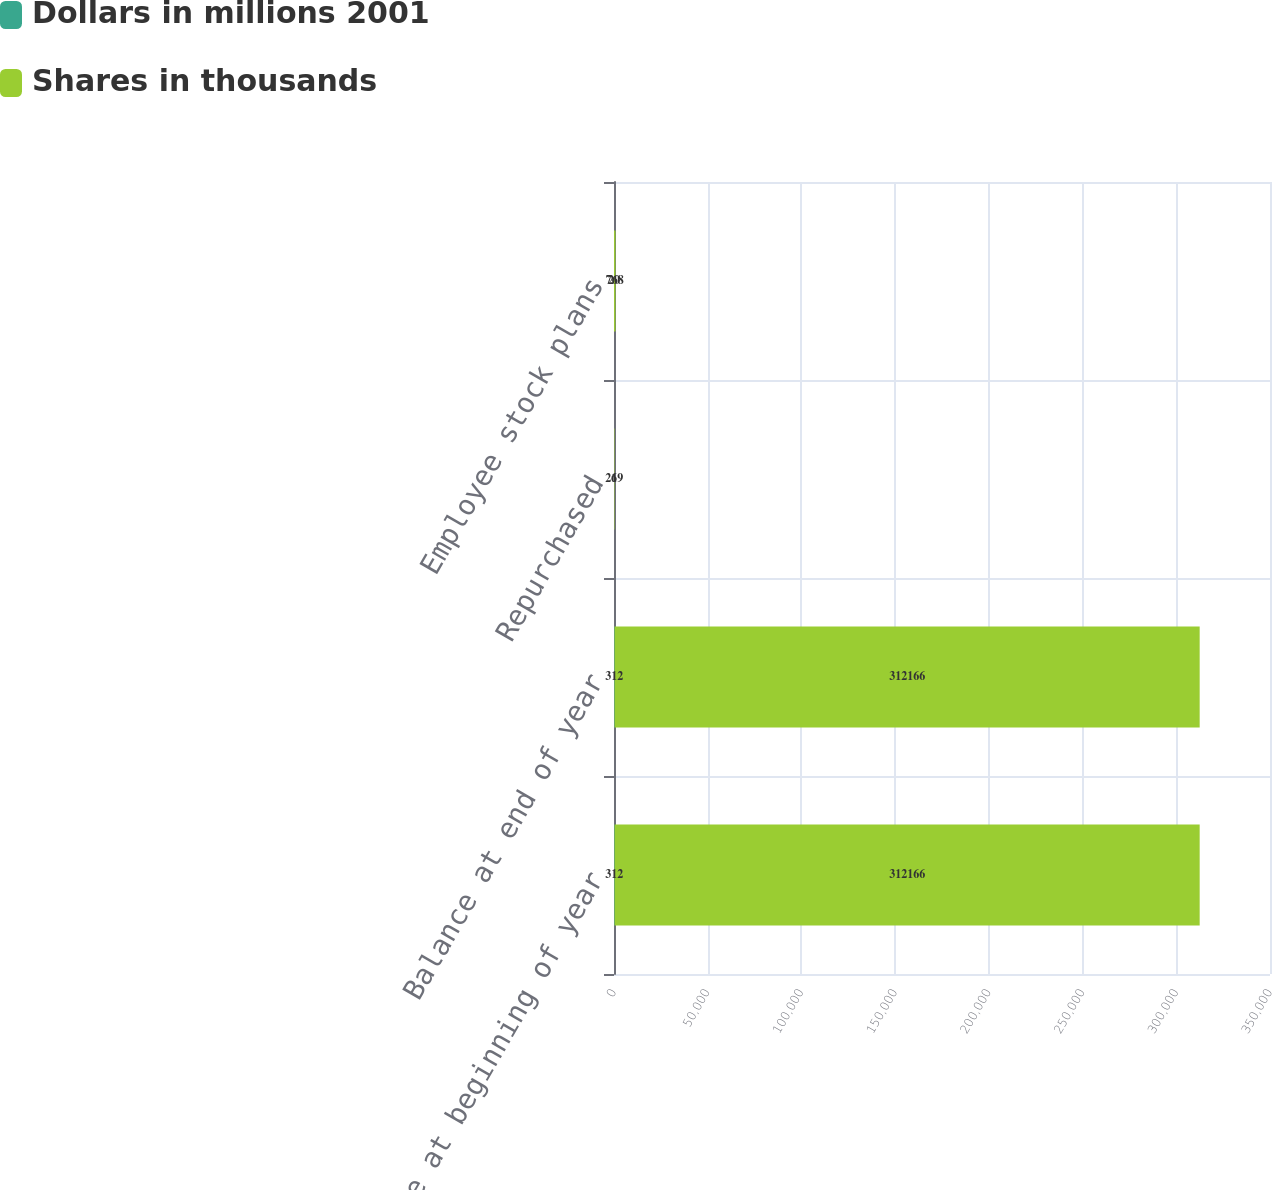Convert chart. <chart><loc_0><loc_0><loc_500><loc_500><stacked_bar_chart><ecel><fcel>Balance at beginning of year<fcel>Balance at end of year<fcel>Repurchased<fcel>Employee stock plans<nl><fcel>Dollars in millions 2001<fcel>312<fcel>312<fcel>6<fcel>20<nl><fcel>Shares in thousands<fcel>312166<fcel>312166<fcel>219<fcel>768<nl></chart> 